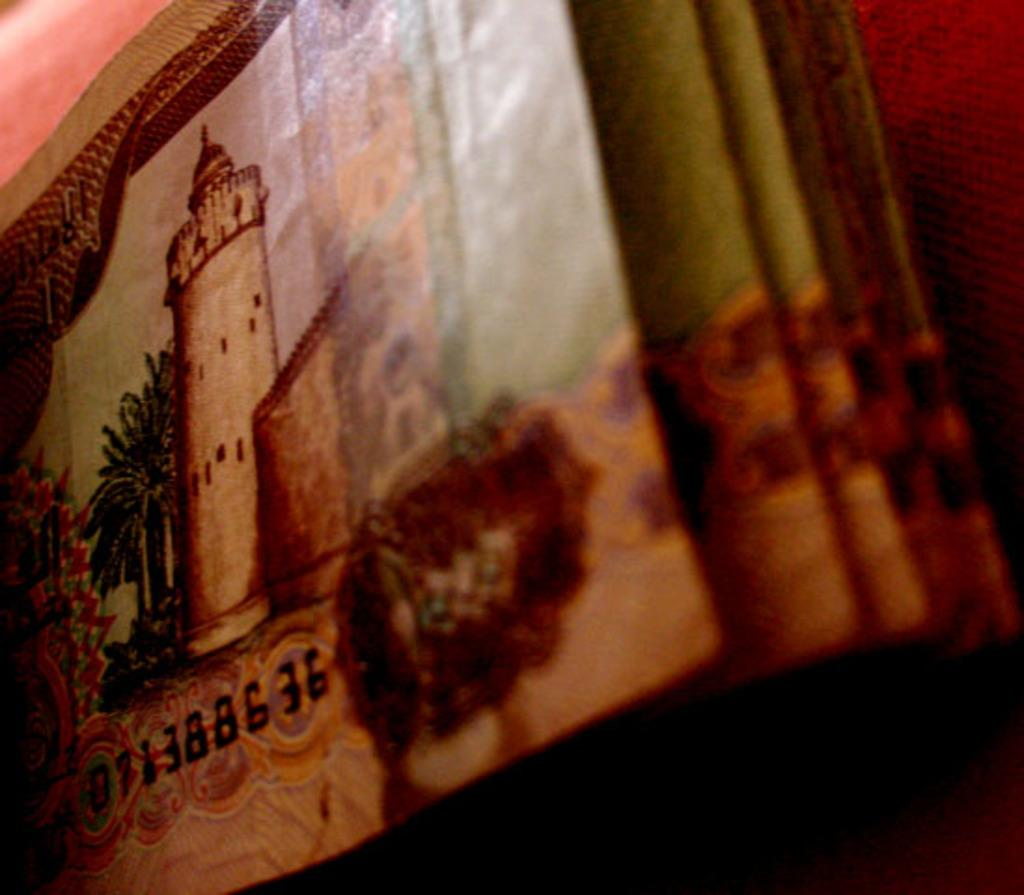<image>
Provide a brief description of the given image. A macro photo of old paper money with a serial D71388636. 